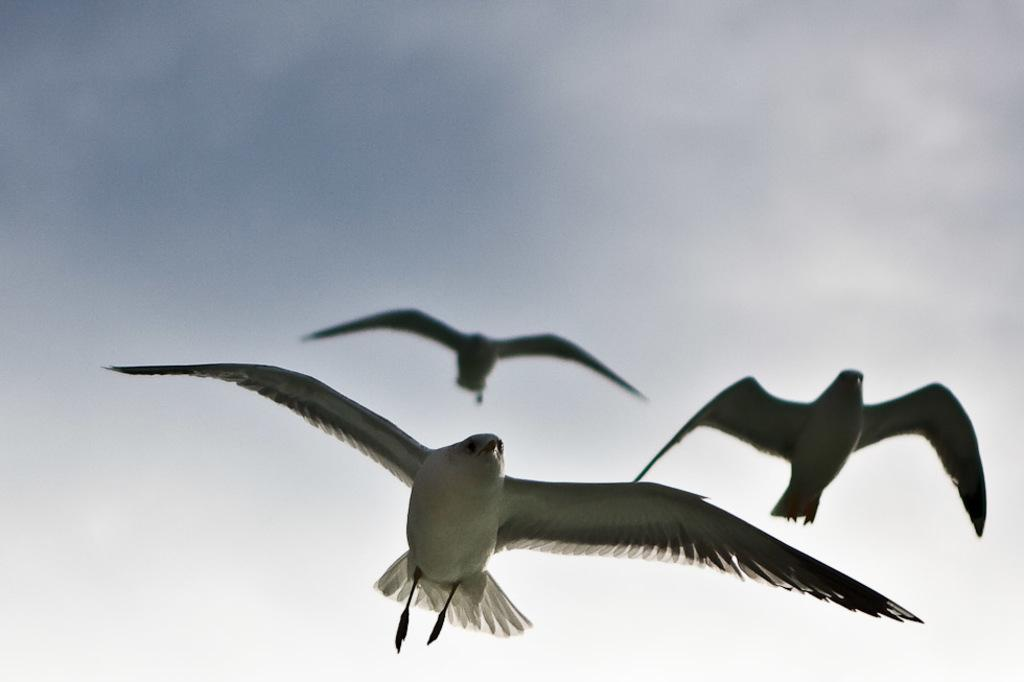How many birds can be seen in the image? There are three birds in the image. What are the birds doing in the image? The birds are flying. What can be seen in the background of the image? The sky is visible in the background of the image. How many clocks are visible in the image? There are no clocks present in the image; it features three birds flying in the sky. Are there any children playing in the image? There are no children present in the image; it features three birds flying in the sky. 